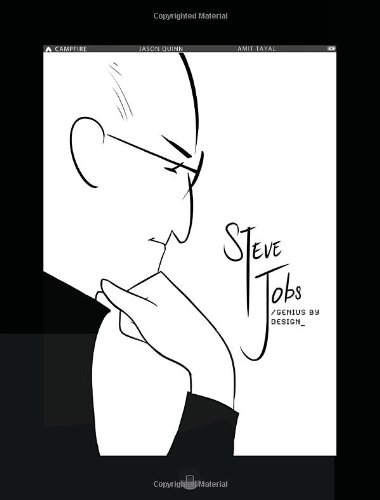What is unique about this book's illustration style? The illustration style of this book employs a minimalist and clean design, emphasizing bold lines and limited color palettes to focus attention on Steve Jobs' distinctive qualities and moments from his life. 